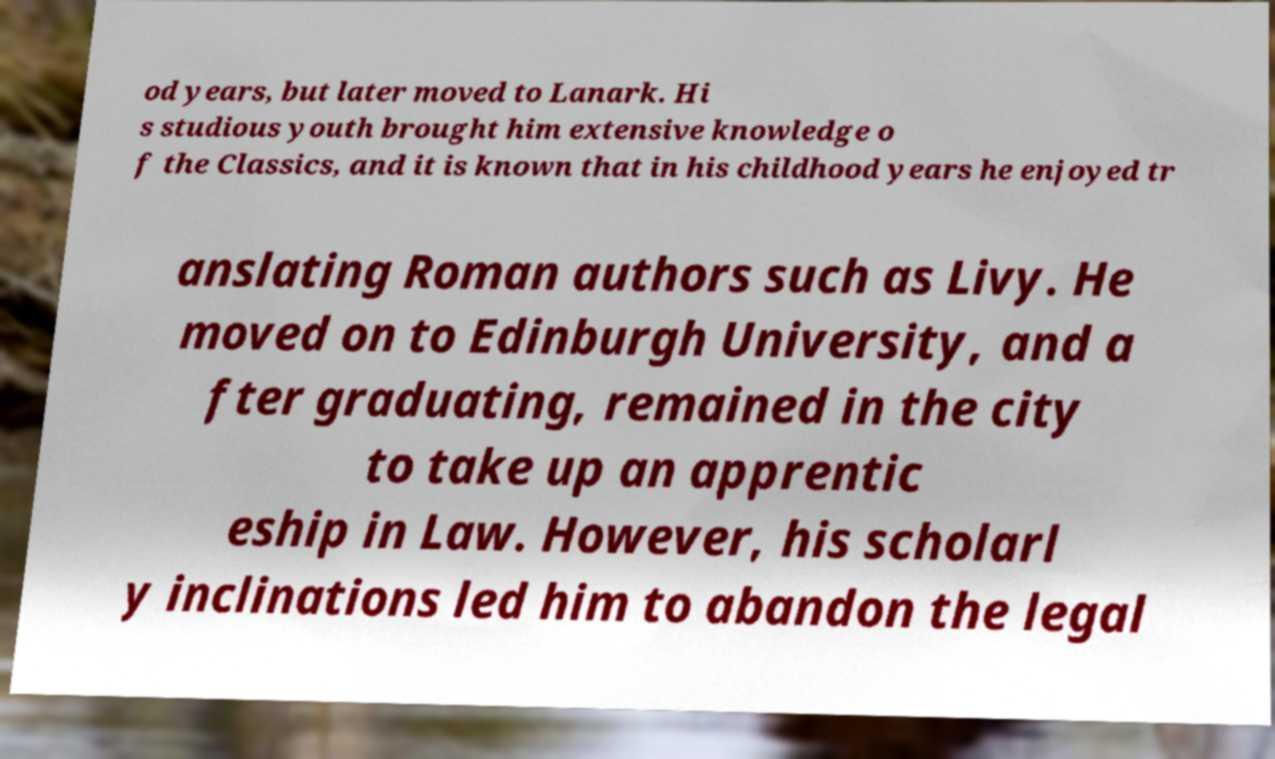Please identify and transcribe the text found in this image. od years, but later moved to Lanark. Hi s studious youth brought him extensive knowledge o f the Classics, and it is known that in his childhood years he enjoyed tr anslating Roman authors such as Livy. He moved on to Edinburgh University, and a fter graduating, remained in the city to take up an apprentic eship in Law. However, his scholarl y inclinations led him to abandon the legal 